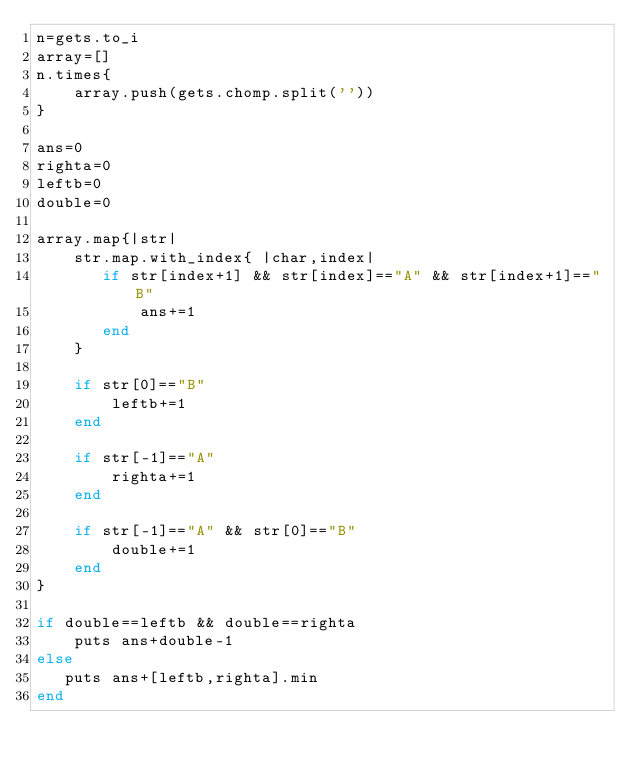Convert code to text. <code><loc_0><loc_0><loc_500><loc_500><_Ruby_>n=gets.to_i
array=[]
n.times{
    array.push(gets.chomp.split(''))
}

ans=0
righta=0
leftb=0
double=0

array.map{|str|
    str.map.with_index{ |char,index|
       if str[index+1] && str[index]=="A" && str[index+1]=="B"
           ans+=1
       end
    }
    
    if str[0]=="B"
        leftb+=1
    end
    
    if str[-1]=="A"
        righta+=1
    end
    
    if str[-1]=="A" && str[0]=="B"
        double+=1
    end
}

if double==leftb && double==righta
    puts ans+double-1
else
   puts ans+[leftb,righta].min 
end</code> 